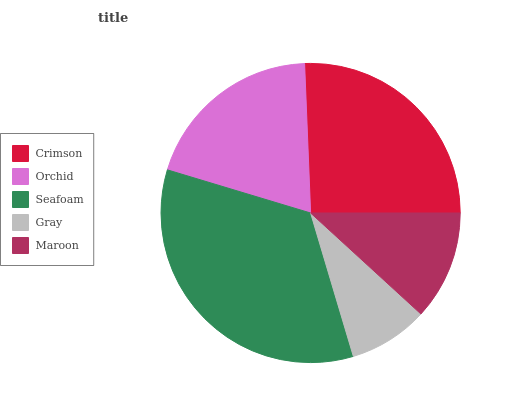Is Gray the minimum?
Answer yes or no. Yes. Is Seafoam the maximum?
Answer yes or no. Yes. Is Orchid the minimum?
Answer yes or no. No. Is Orchid the maximum?
Answer yes or no. No. Is Crimson greater than Orchid?
Answer yes or no. Yes. Is Orchid less than Crimson?
Answer yes or no. Yes. Is Orchid greater than Crimson?
Answer yes or no. No. Is Crimson less than Orchid?
Answer yes or no. No. Is Orchid the high median?
Answer yes or no. Yes. Is Orchid the low median?
Answer yes or no. Yes. Is Gray the high median?
Answer yes or no. No. Is Crimson the low median?
Answer yes or no. No. 